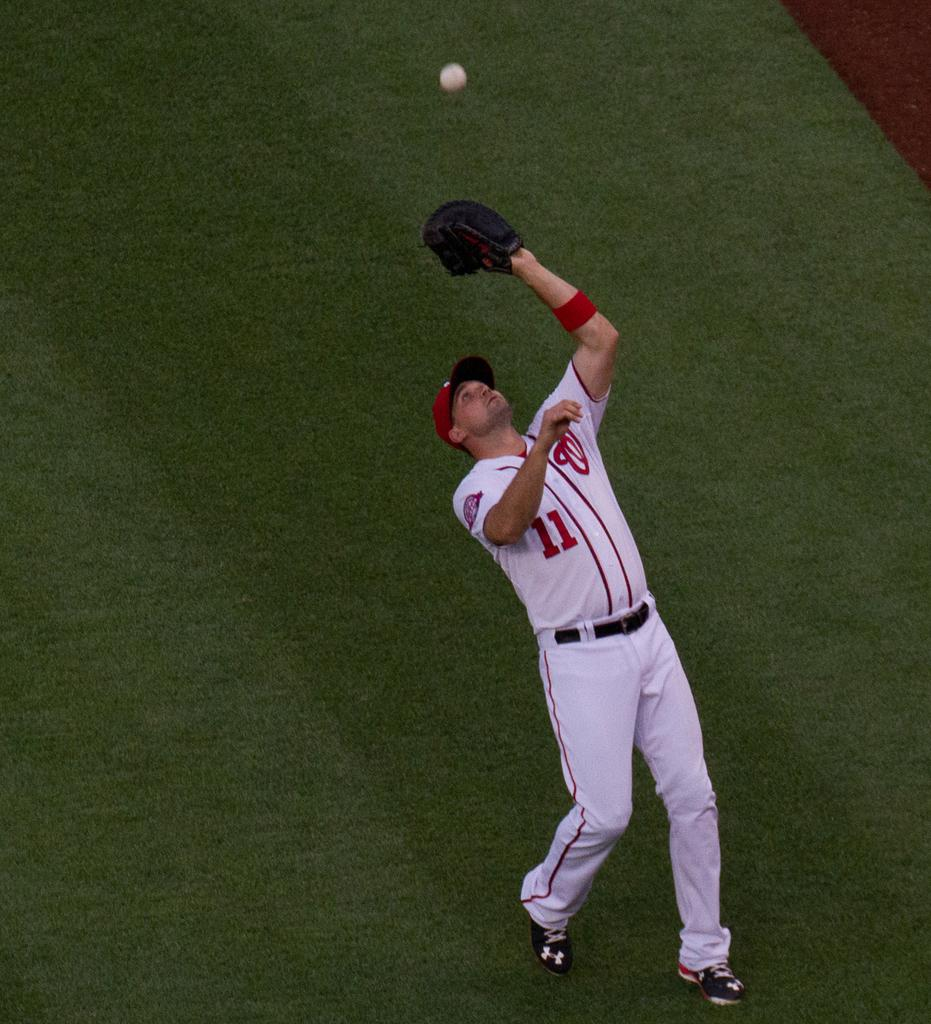<image>
Present a compact description of the photo's key features. player number 11 leans backwards as he tries to catch the ball 